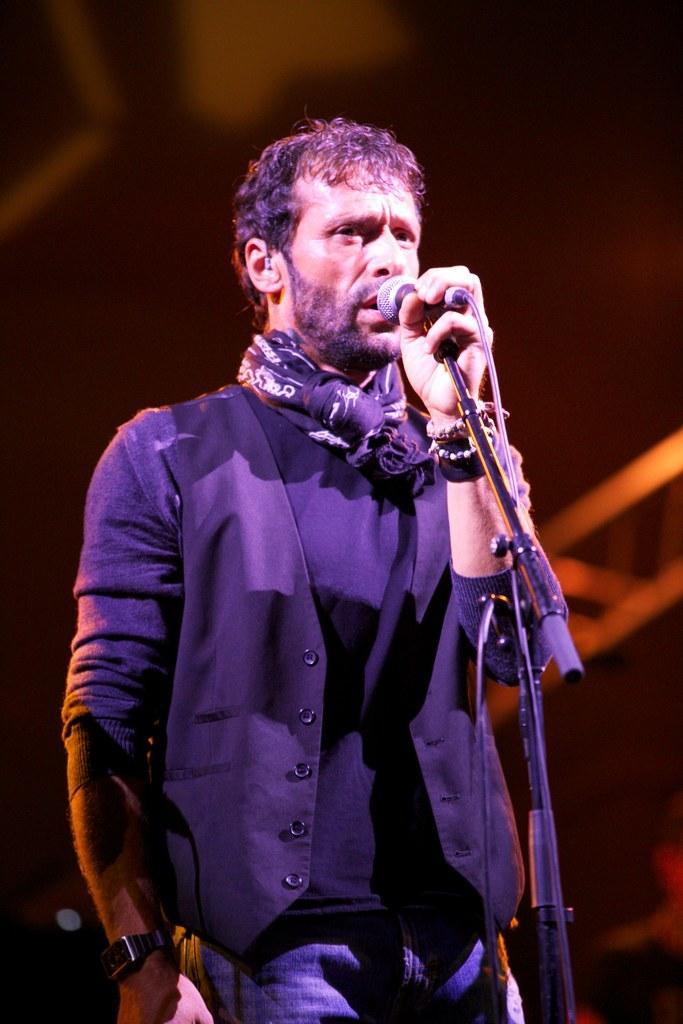Could you give a brief overview of what you see in this image? In this image I can see the person standing in-front of the mic. The person is wearing the black color dress and also holding the mic. 